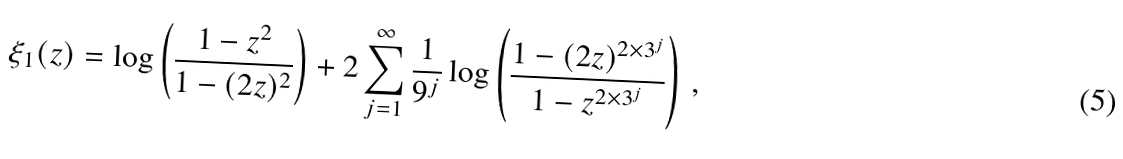Convert formula to latex. <formula><loc_0><loc_0><loc_500><loc_500>\xi _ { 1 } ( z ) = \log \left ( \frac { 1 - z ^ { 2 } } { 1 - ( 2 z ) ^ { 2 } } \right ) + 2 \sum _ { j = 1 } ^ { \infty } \frac { 1 } { 9 ^ { j } } \log \left ( \frac { 1 - ( 2 z ) ^ { 2 \times 3 ^ { j } } } { 1 - z ^ { 2 \times 3 ^ { j } } } \right ) { \, } ,</formula> 